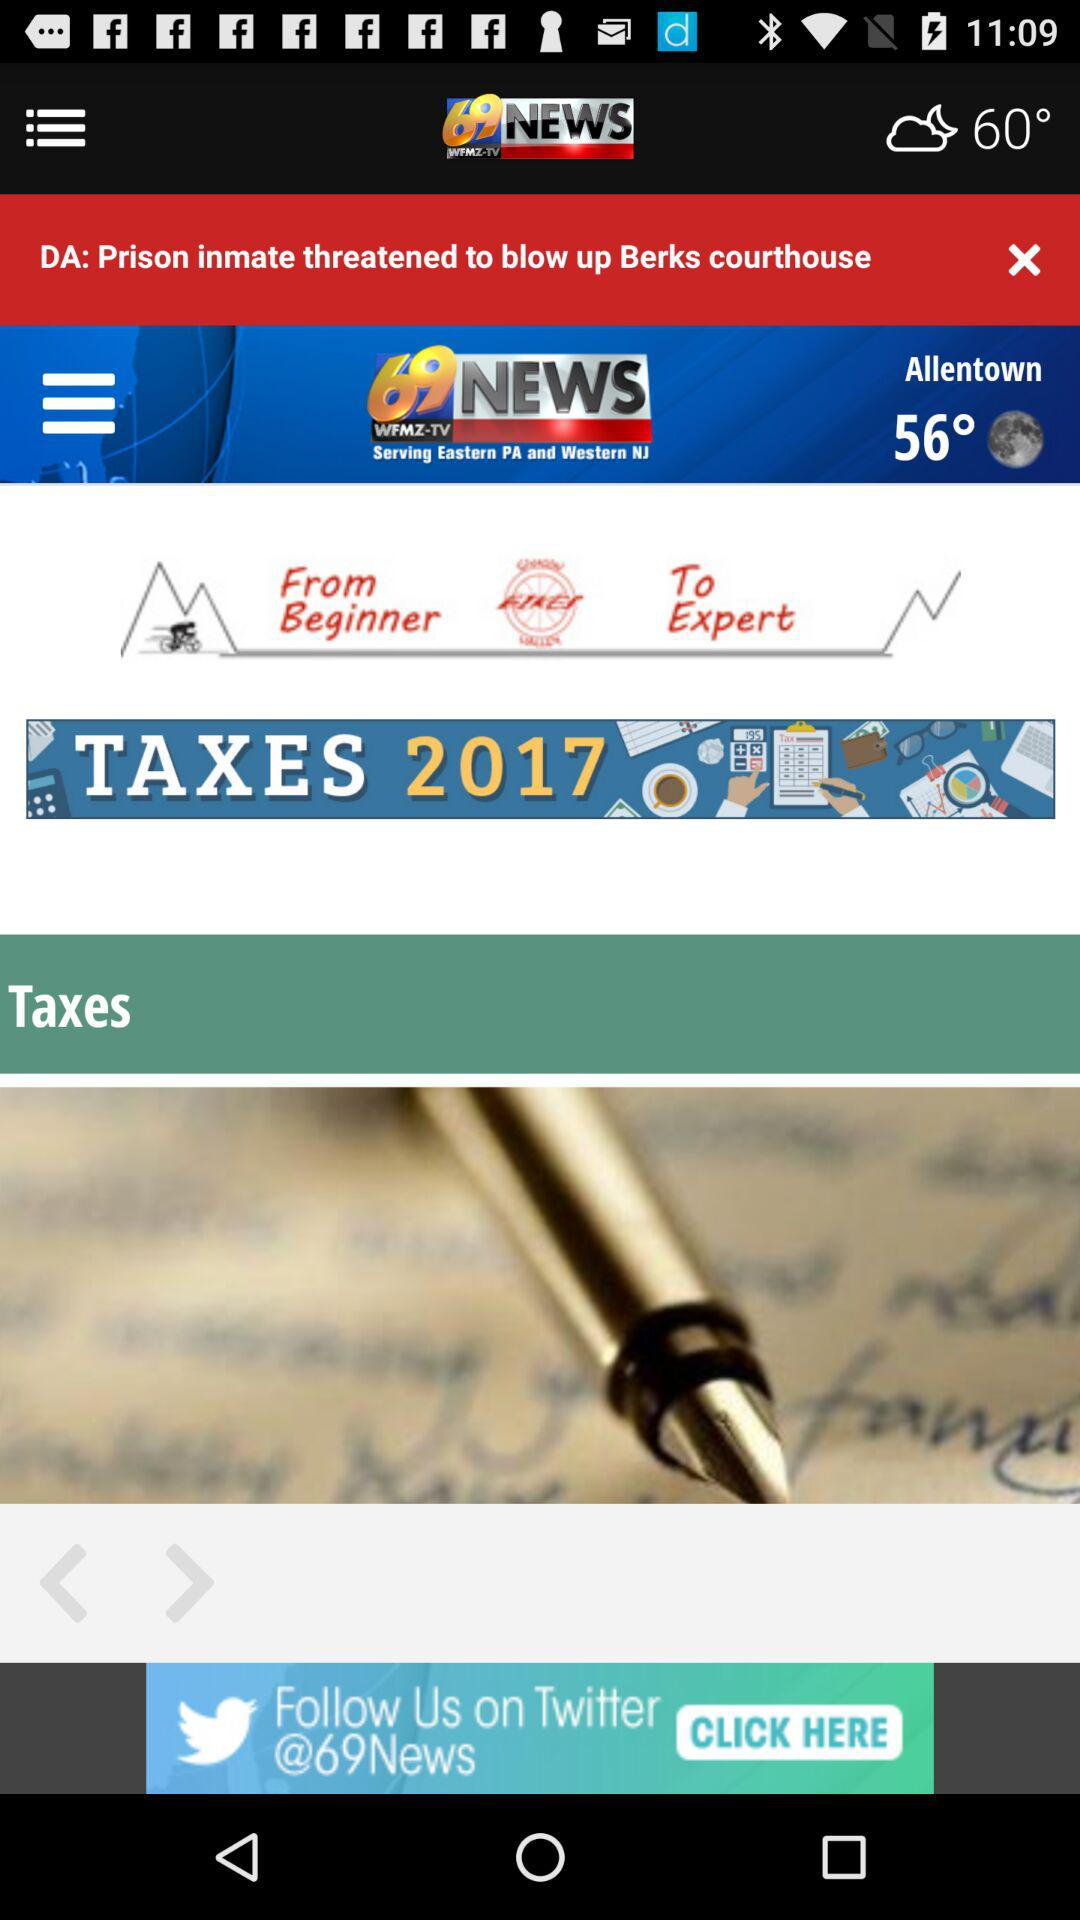What is today's temperature? Today's temperature is 60°. 